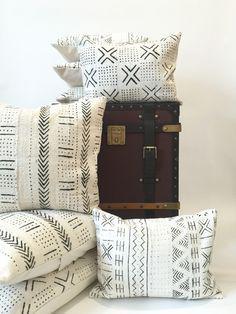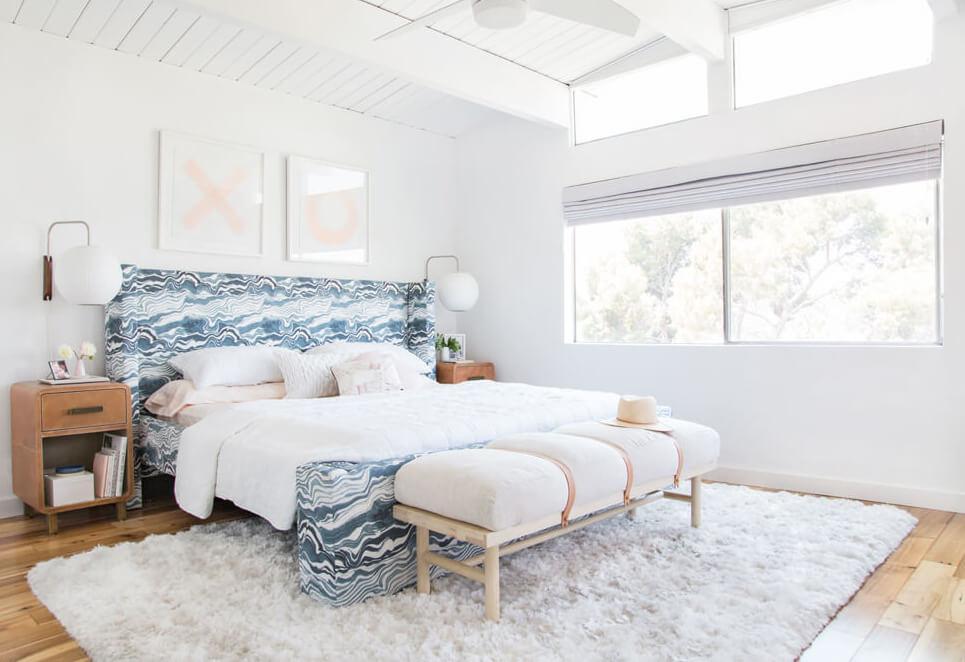The first image is the image on the left, the second image is the image on the right. For the images shown, is this caption "An image contains a person sitting on a couch." true? Answer yes or no. No. The first image is the image on the left, the second image is the image on the right. Given the left and right images, does the statement "There is a person sitting on a couch." hold true? Answer yes or no. No. 